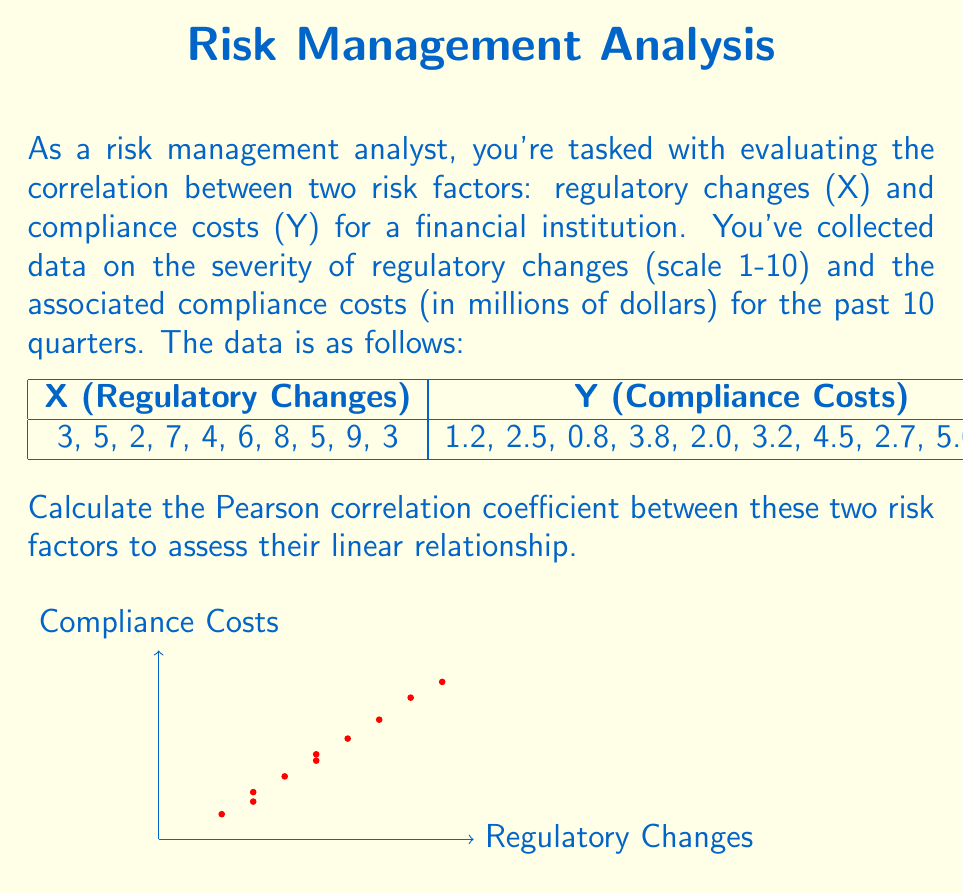Solve this math problem. To calculate the Pearson correlation coefficient (r), we'll use the formula:

$$ r = \frac{\sum_{i=1}^{n} (x_i - \bar{x})(y_i - \bar{y})}{\sqrt{\sum_{i=1}^{n} (x_i - \bar{x})^2 \sum_{i=1}^{n} (y_i - \bar{y})^2}} $$

Where $\bar{x}$ and $\bar{y}$ are the means of X and Y respectively.

Step 1: Calculate the means
$\bar{x} = \frac{3+5+2+7+4+6+8+5+9+3}{10} = 5.2$
$\bar{y} = \frac{1.2+2.5+0.8+3.8+2.0+3.2+4.5+2.7+5.0+1.5}{10} = 2.72$

Step 2: Calculate $(x_i - \bar{x})$, $(y_i - \bar{y})$, $(x_i - \bar{x})^2$, $(y_i - \bar{y})^2$, and $(x_i - \bar{x})(y_i - \bar{y})$ for each pair

Step 3: Sum up the values
$\sum (x_i - \bar{x})(y_i - \bar{y}) = 24.24$
$\sum (x_i - \bar{x})^2 = 52.4$
$\sum (y_i - \bar{y})^2 = 14.1416$

Step 4: Apply the formula
$$ r = \frac{24.24}{\sqrt{52.4 \times 14.1416}} = \frac{24.24}{27.1853} \approx 0.8916 $$
Answer: $r \approx 0.8916$ 